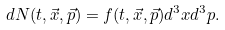<formula> <loc_0><loc_0><loc_500><loc_500>d N ( t , \vec { x } , \vec { p } ) = f ( t , \vec { x } , \vec { p } ) d ^ { 3 } x d ^ { 3 } p .</formula> 